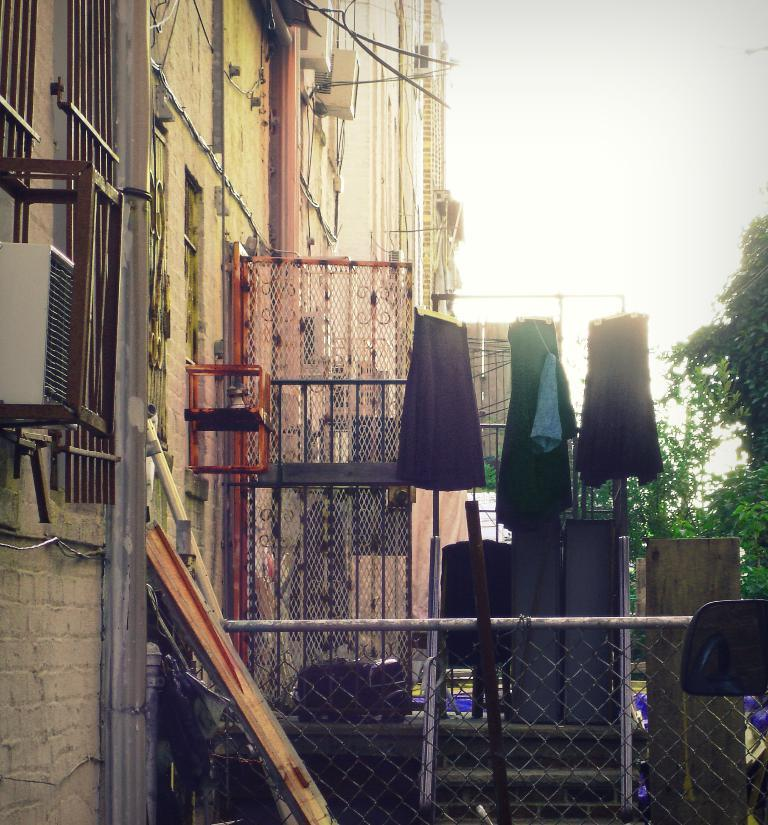What type of structures can be seen in the image? There are buildings in the image. What natural elements are present in the image? There are trees in the image. What items are visible that might be related to clothing? There are clothes visible in the image. What type of barrier can be seen in the image? There is a metal fence in the image. What material is used for the planks in the image? There are wooden planks in the image. How would you describe the weather based on the sky in the image? The sky is cloudy in the image. What type of corn can be seen growing in the image? There is no corn present in the image. How does the milk flow in the image? There is no milk present in the image. 